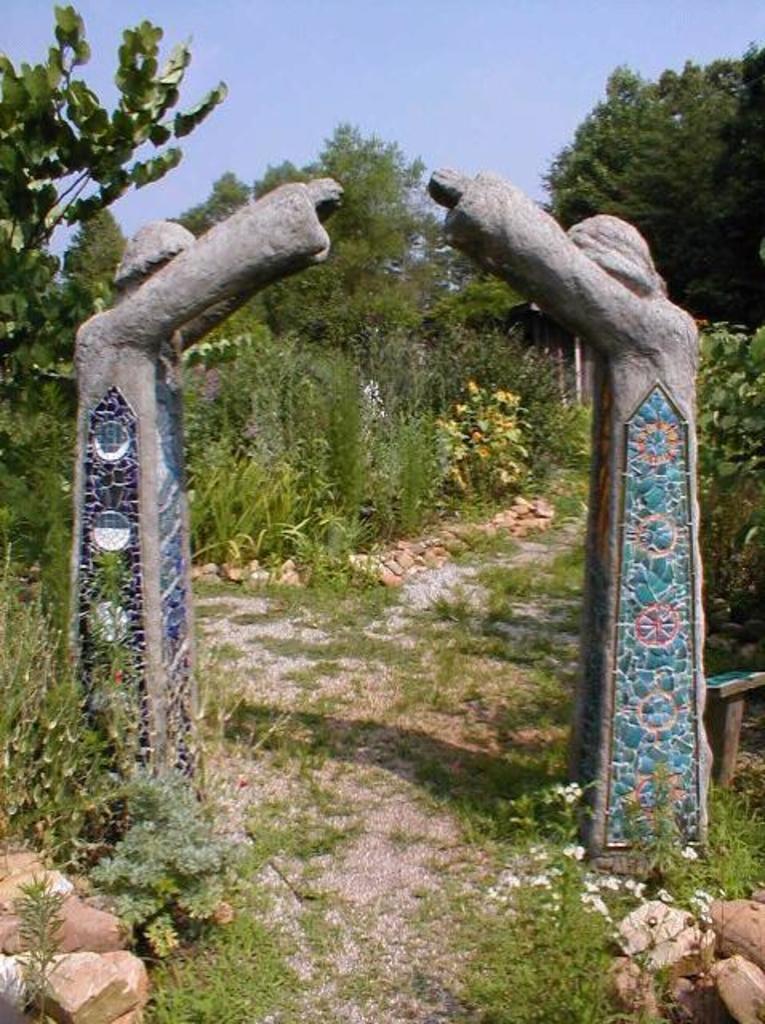Please provide a concise description of this image. In this image I can see two rock statues of a person standing which are blue, green and ash in color, few rocks which are brown in color, some grass, few flowers which are white and yellow in color and few plants. In the background I can see few trees and the sky. 